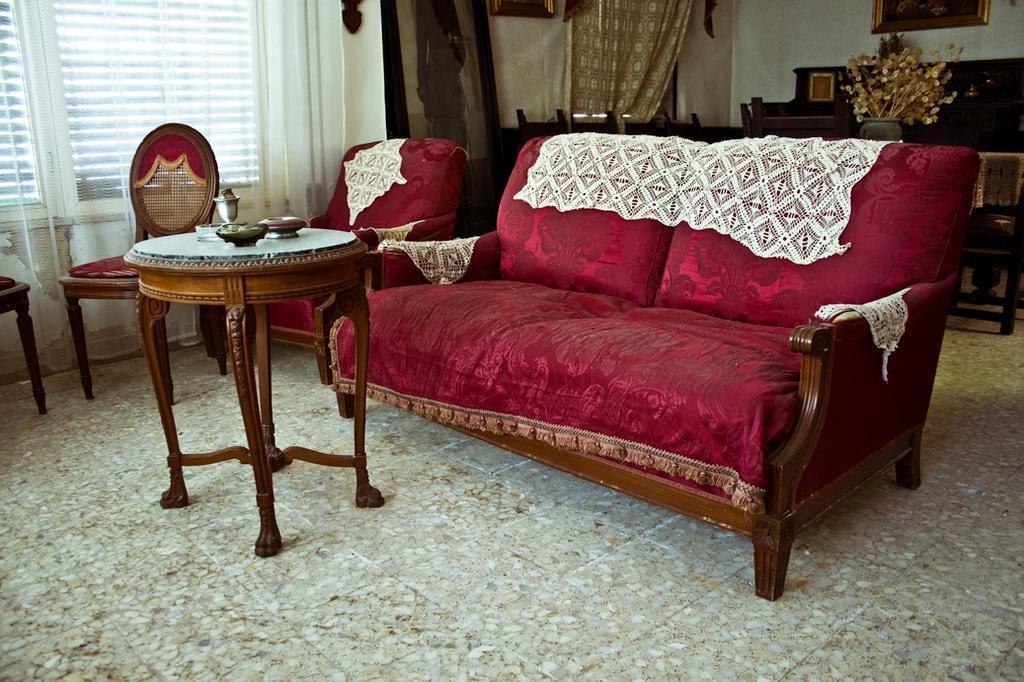Can you describe this image briefly? In the center of the image we can see sofa and stool. In the background we can see chairs, window, curtain, photo frame and wall. 